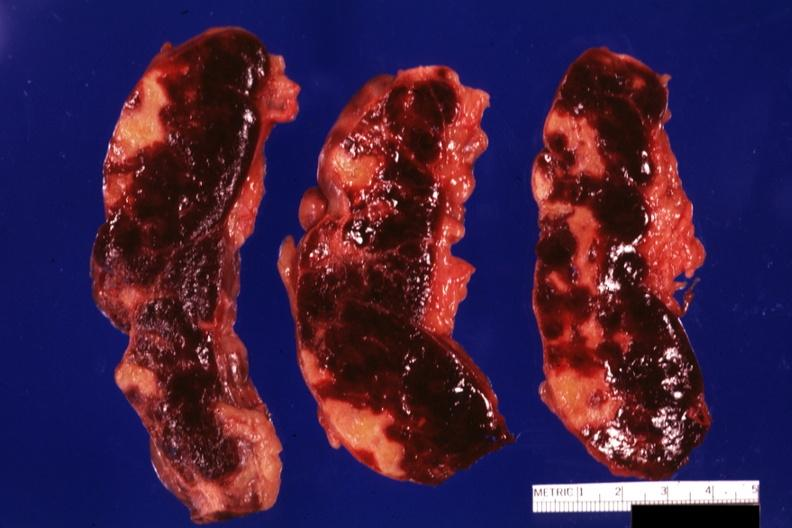what is present?
Answer the question using a single word or phrase. Infarcts 